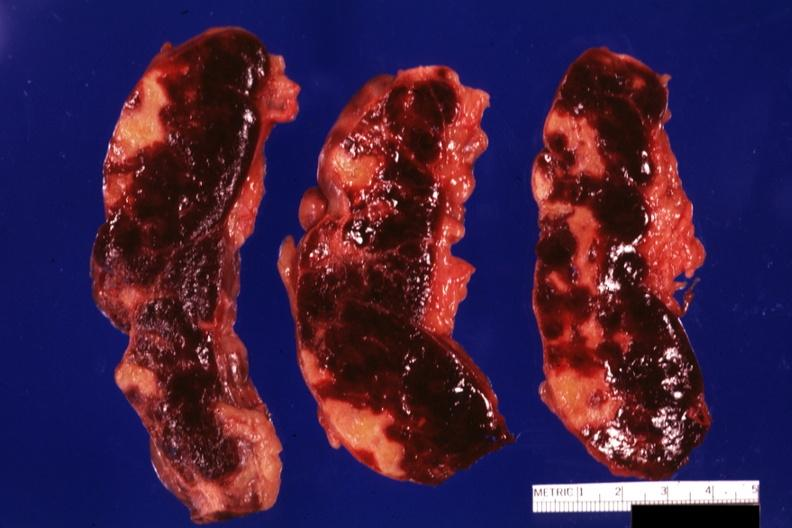what is present?
Answer the question using a single word or phrase. Infarcts 